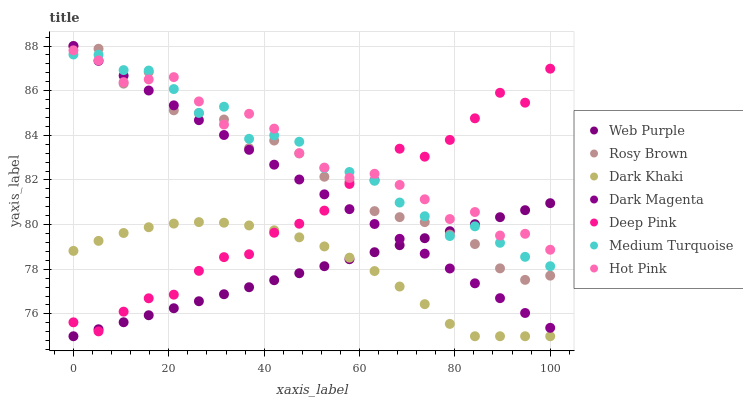Does Web Purple have the minimum area under the curve?
Answer yes or no. Yes. Does Hot Pink have the maximum area under the curve?
Answer yes or no. Yes. Does Dark Magenta have the minimum area under the curve?
Answer yes or no. No. Does Dark Magenta have the maximum area under the curve?
Answer yes or no. No. Is Web Purple the smoothest?
Answer yes or no. Yes. Is Rosy Brown the roughest?
Answer yes or no. Yes. Is Dark Magenta the smoothest?
Answer yes or no. No. Is Dark Magenta the roughest?
Answer yes or no. No. Does Dark Khaki have the lowest value?
Answer yes or no. Yes. Does Dark Magenta have the lowest value?
Answer yes or no. No. Does Rosy Brown have the highest value?
Answer yes or no. Yes. Does Dark Khaki have the highest value?
Answer yes or no. No. Is Dark Khaki less than Hot Pink?
Answer yes or no. Yes. Is Rosy Brown greater than Dark Khaki?
Answer yes or no. Yes. Does Web Purple intersect Dark Magenta?
Answer yes or no. Yes. Is Web Purple less than Dark Magenta?
Answer yes or no. No. Is Web Purple greater than Dark Magenta?
Answer yes or no. No. Does Dark Khaki intersect Hot Pink?
Answer yes or no. No. 